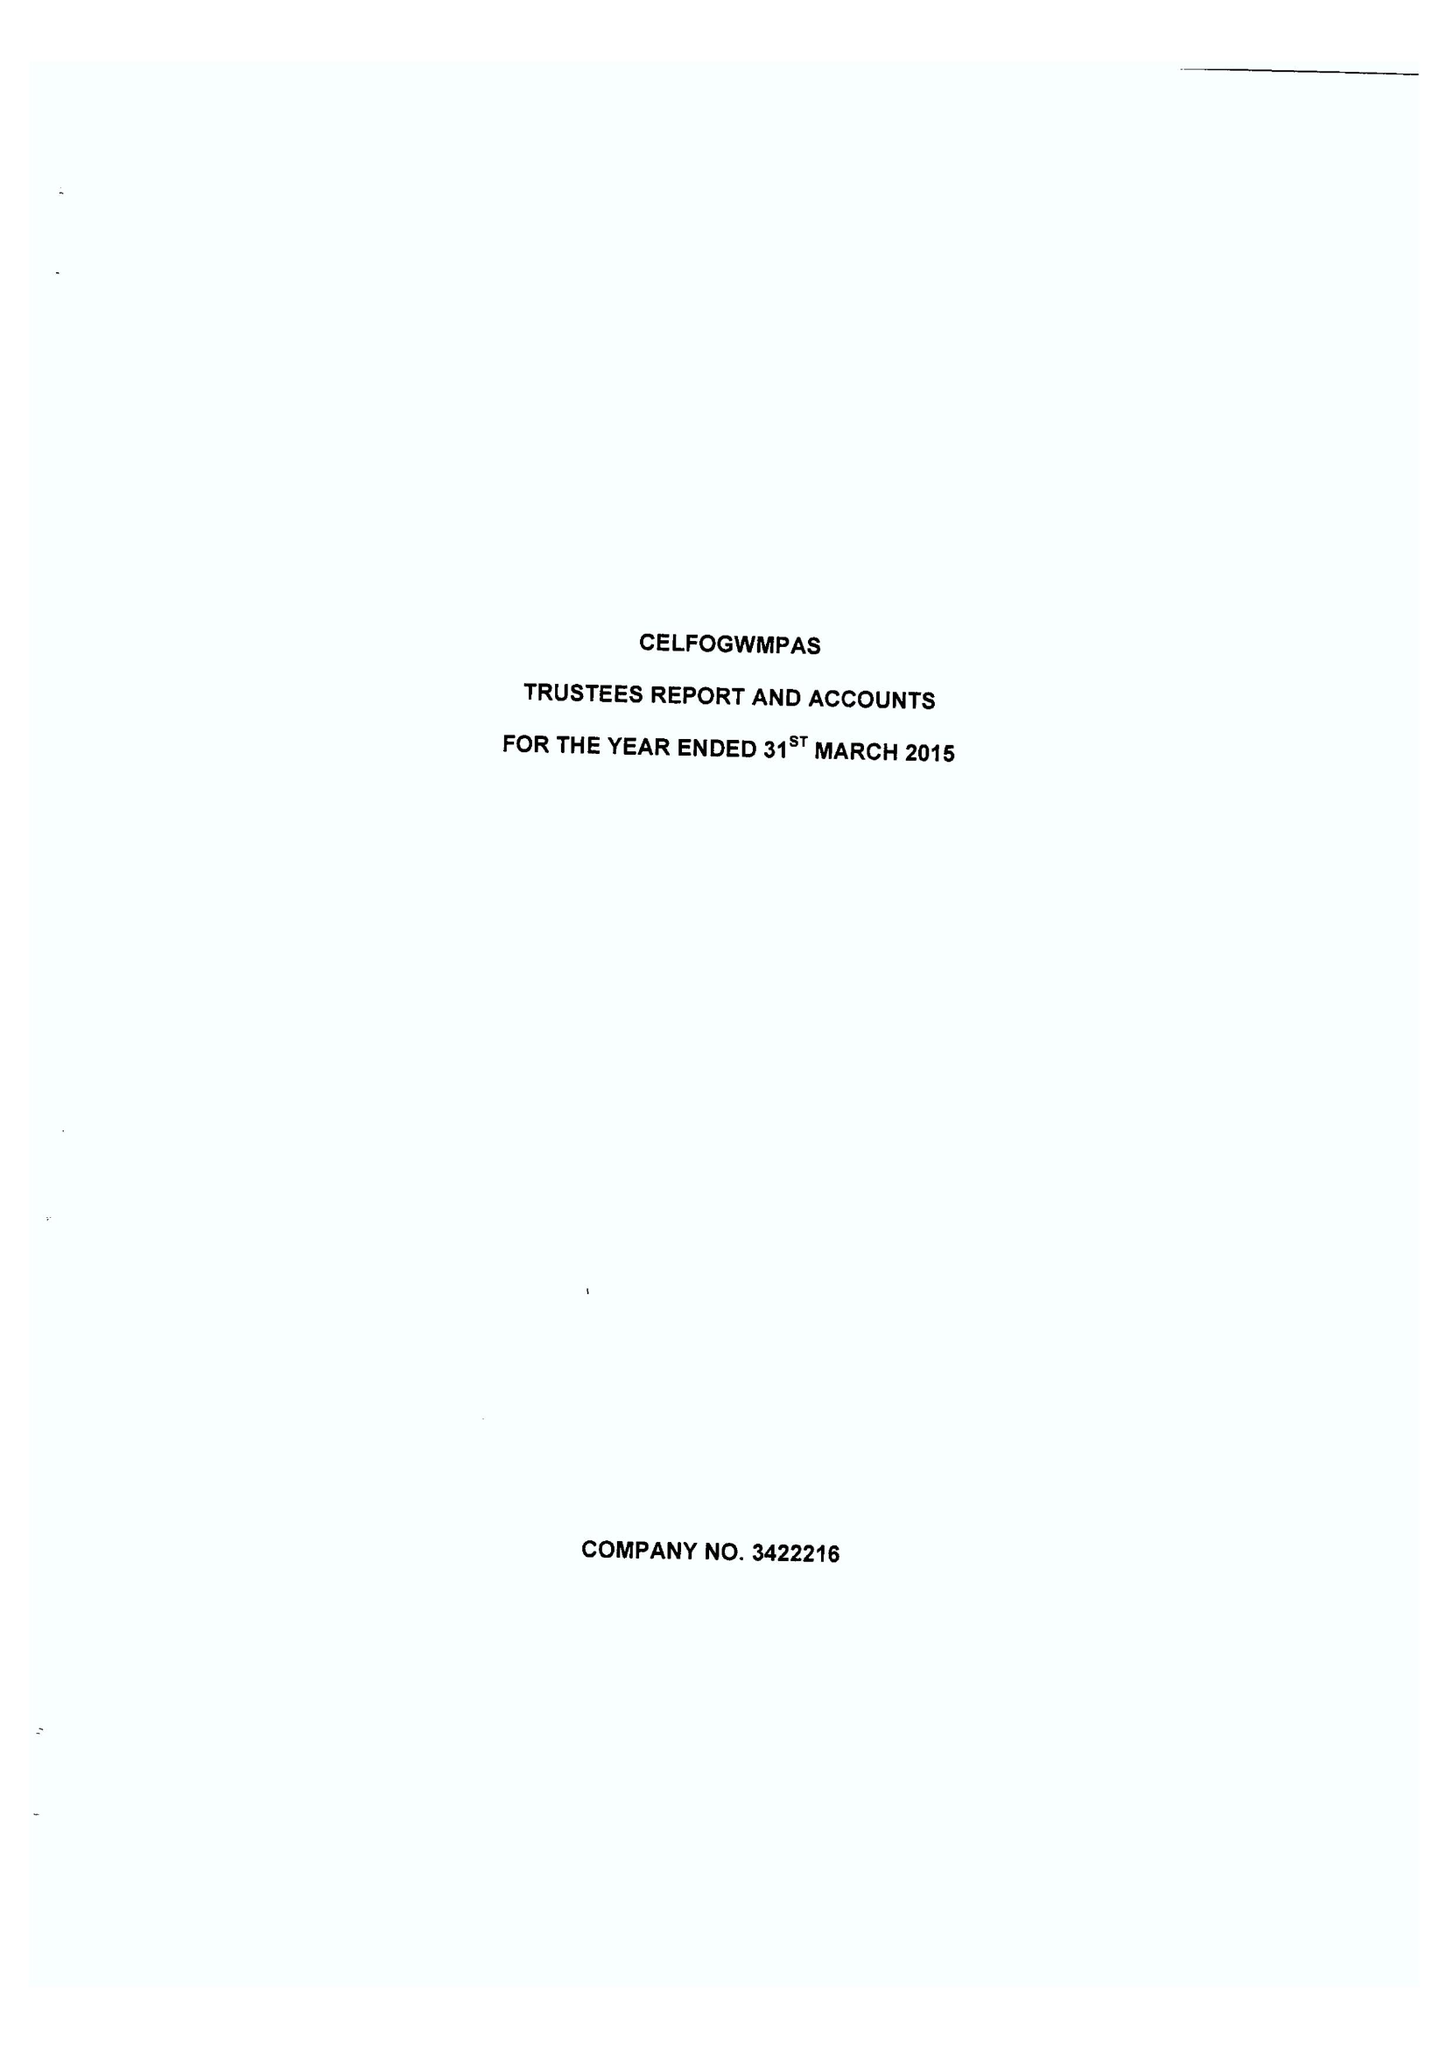What is the value for the address__street_line?
Answer the question using a single word or phrase. TREMONT ROAD 